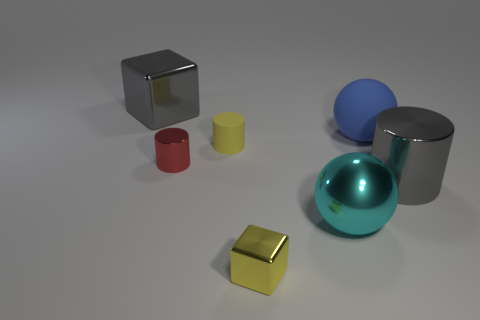Do the big blue object and the small yellow thing in front of the yellow cylinder have the same shape?
Your answer should be very brief. No. There is a metal cylinder that is the same color as the big block; what is its size?
Offer a terse response. Large. How many things are small brown balls or big gray things?
Give a very brief answer. 2. There is a big gray thing in front of the large metal object that is behind the big blue matte sphere; what is its shape?
Give a very brief answer. Cylinder. There is a big gray thing to the right of the gray block; does it have the same shape as the tiny yellow shiny object?
Your answer should be very brief. No. There is a yellow block that is the same material as the big gray cylinder; what is its size?
Offer a very short reply. Small. How many objects are either large balls right of the cyan object or shiny things behind the large matte object?
Your answer should be very brief. 2. Are there the same number of cyan shiny objects left of the small yellow rubber object and small red shiny things on the left side of the small red thing?
Ensure brevity in your answer.  Yes. What is the color of the sphere that is behind the gray cylinder?
Your answer should be compact. Blue. There is a large matte thing; does it have the same color as the shiny object behind the big rubber sphere?
Offer a terse response. No. 